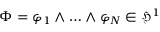<formula> <loc_0><loc_0><loc_500><loc_500>\Phi = \varphi _ { 1 } \wedge \dots \wedge \varphi _ { N } \in \mathfrak { H } ^ { 1 }</formula> 